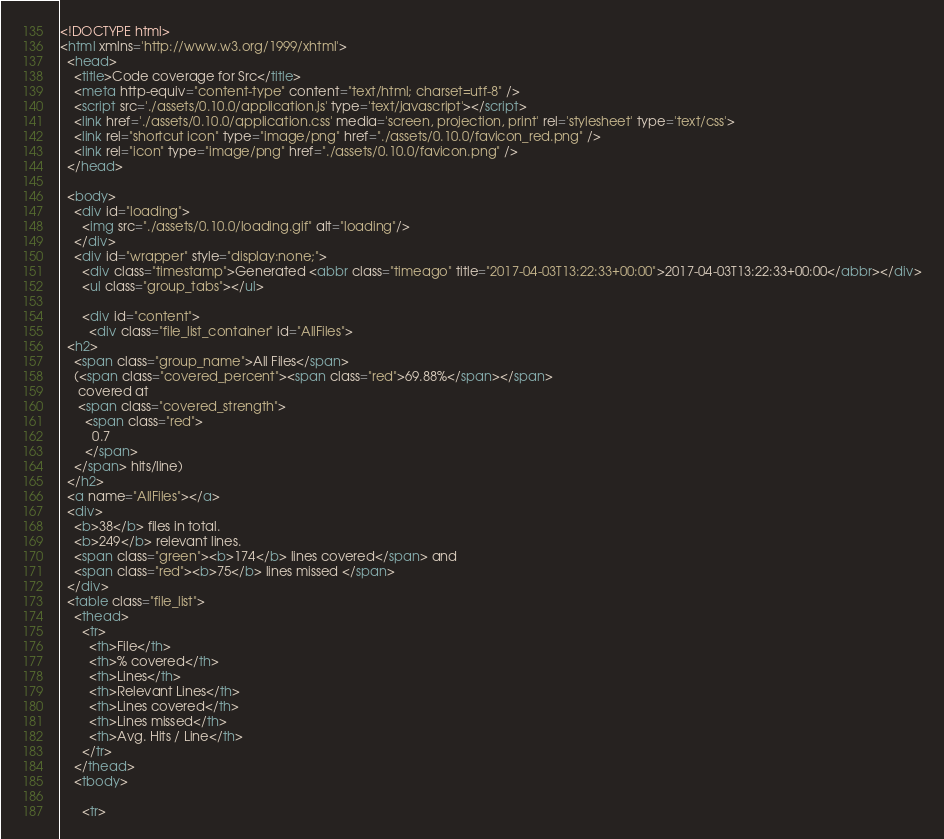Convert code to text. <code><loc_0><loc_0><loc_500><loc_500><_HTML_><!DOCTYPE html>
<html xmlns='http://www.w3.org/1999/xhtml'>
  <head>
    <title>Code coverage for Src</title>
    <meta http-equiv="content-type" content="text/html; charset=utf-8" />
    <script src='./assets/0.10.0/application.js' type='text/javascript'></script>    
    <link href='./assets/0.10.0/application.css' media='screen, projection, print' rel='stylesheet' type='text/css'>
    <link rel="shortcut icon" type="image/png" href="./assets/0.10.0/favicon_red.png" />
    <link rel="icon" type="image/png" href="./assets/0.10.0/favicon.png" />
  </head>
  
  <body>
    <div id="loading">
      <img src="./assets/0.10.0/loading.gif" alt="loading"/>
    </div>
    <div id="wrapper" style="display:none;">
      <div class="timestamp">Generated <abbr class="timeago" title="2017-04-03T13:22:33+00:00">2017-04-03T13:22:33+00:00</abbr></div>
      <ul class="group_tabs"></ul>

      <div id="content">
        <div class="file_list_container" id="AllFiles">
  <h2>
    <span class="group_name">All Files</span>
    (<span class="covered_percent"><span class="red">69.88%</span></span>
     covered at
     <span class="covered_strength">
       <span class="red">
         0.7
       </span>
    </span> hits/line)
  </h2>
  <a name="AllFiles"></a>
  <div>
    <b>38</b> files in total.
    <b>249</b> relevant lines. 
    <span class="green"><b>174</b> lines covered</span> and
    <span class="red"><b>75</b> lines missed </span>
  </div>
  <table class="file_list">
    <thead>
      <tr>
        <th>File</th>
        <th>% covered</th>
        <th>Lines</th>
        <th>Relevant Lines</th>
        <th>Lines covered</th>
        <th>Lines missed</th>
        <th>Avg. Hits / Line</th>
      </tr>
    </thead>
    <tbody>
      
      <tr></code> 